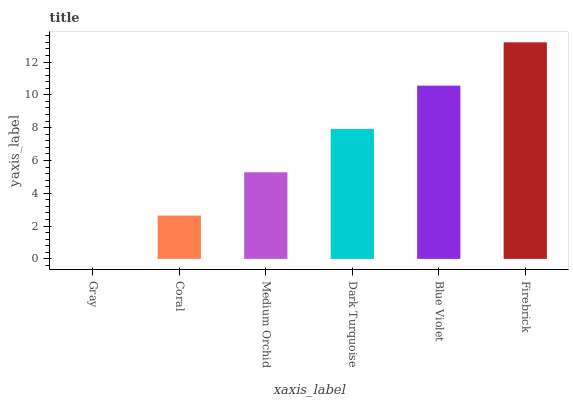Is Coral the minimum?
Answer yes or no. No. Is Coral the maximum?
Answer yes or no. No. Is Coral greater than Gray?
Answer yes or no. Yes. Is Gray less than Coral?
Answer yes or no. Yes. Is Gray greater than Coral?
Answer yes or no. No. Is Coral less than Gray?
Answer yes or no. No. Is Dark Turquoise the high median?
Answer yes or no. Yes. Is Medium Orchid the low median?
Answer yes or no. Yes. Is Medium Orchid the high median?
Answer yes or no. No. Is Gray the low median?
Answer yes or no. No. 